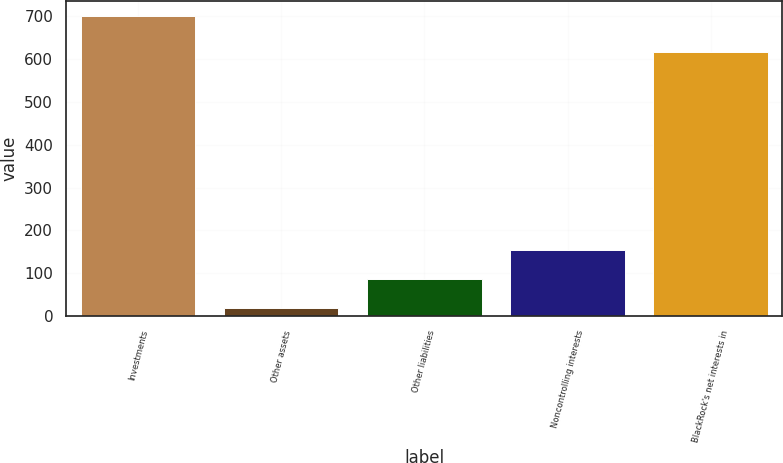<chart> <loc_0><loc_0><loc_500><loc_500><bar_chart><fcel>Investments<fcel>Other assets<fcel>Other liabilities<fcel>Noncontrolling interests<fcel>BlackRock's net interests in<nl><fcel>700<fcel>18<fcel>86.2<fcel>154.4<fcel>616<nl></chart> 